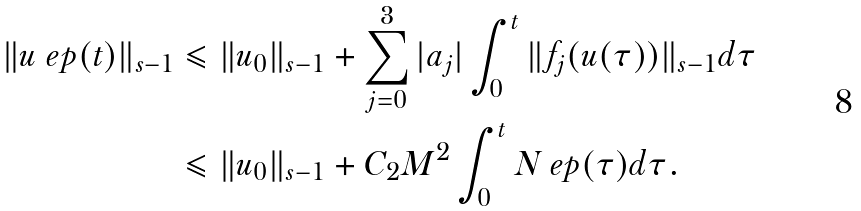Convert formula to latex. <formula><loc_0><loc_0><loc_500><loc_500>\| { u _ { \ } e p ( t ) } \| _ { s - 1 } & \leqslant \| { u _ { 0 } } \| _ { s - 1 } + \sum _ { j = 0 } ^ { 3 } | { a _ { j } } | \int _ { 0 } ^ { t } \| { f _ { j } ( u ( \tau ) ) } \| _ { s - 1 } d \tau \\ & \leqslant \| { u _ { 0 } } \| _ { s - 1 } + C _ { 2 } M ^ { 2 } \int _ { 0 } ^ { t } N _ { \ } e p ( \tau ) d \tau .</formula> 